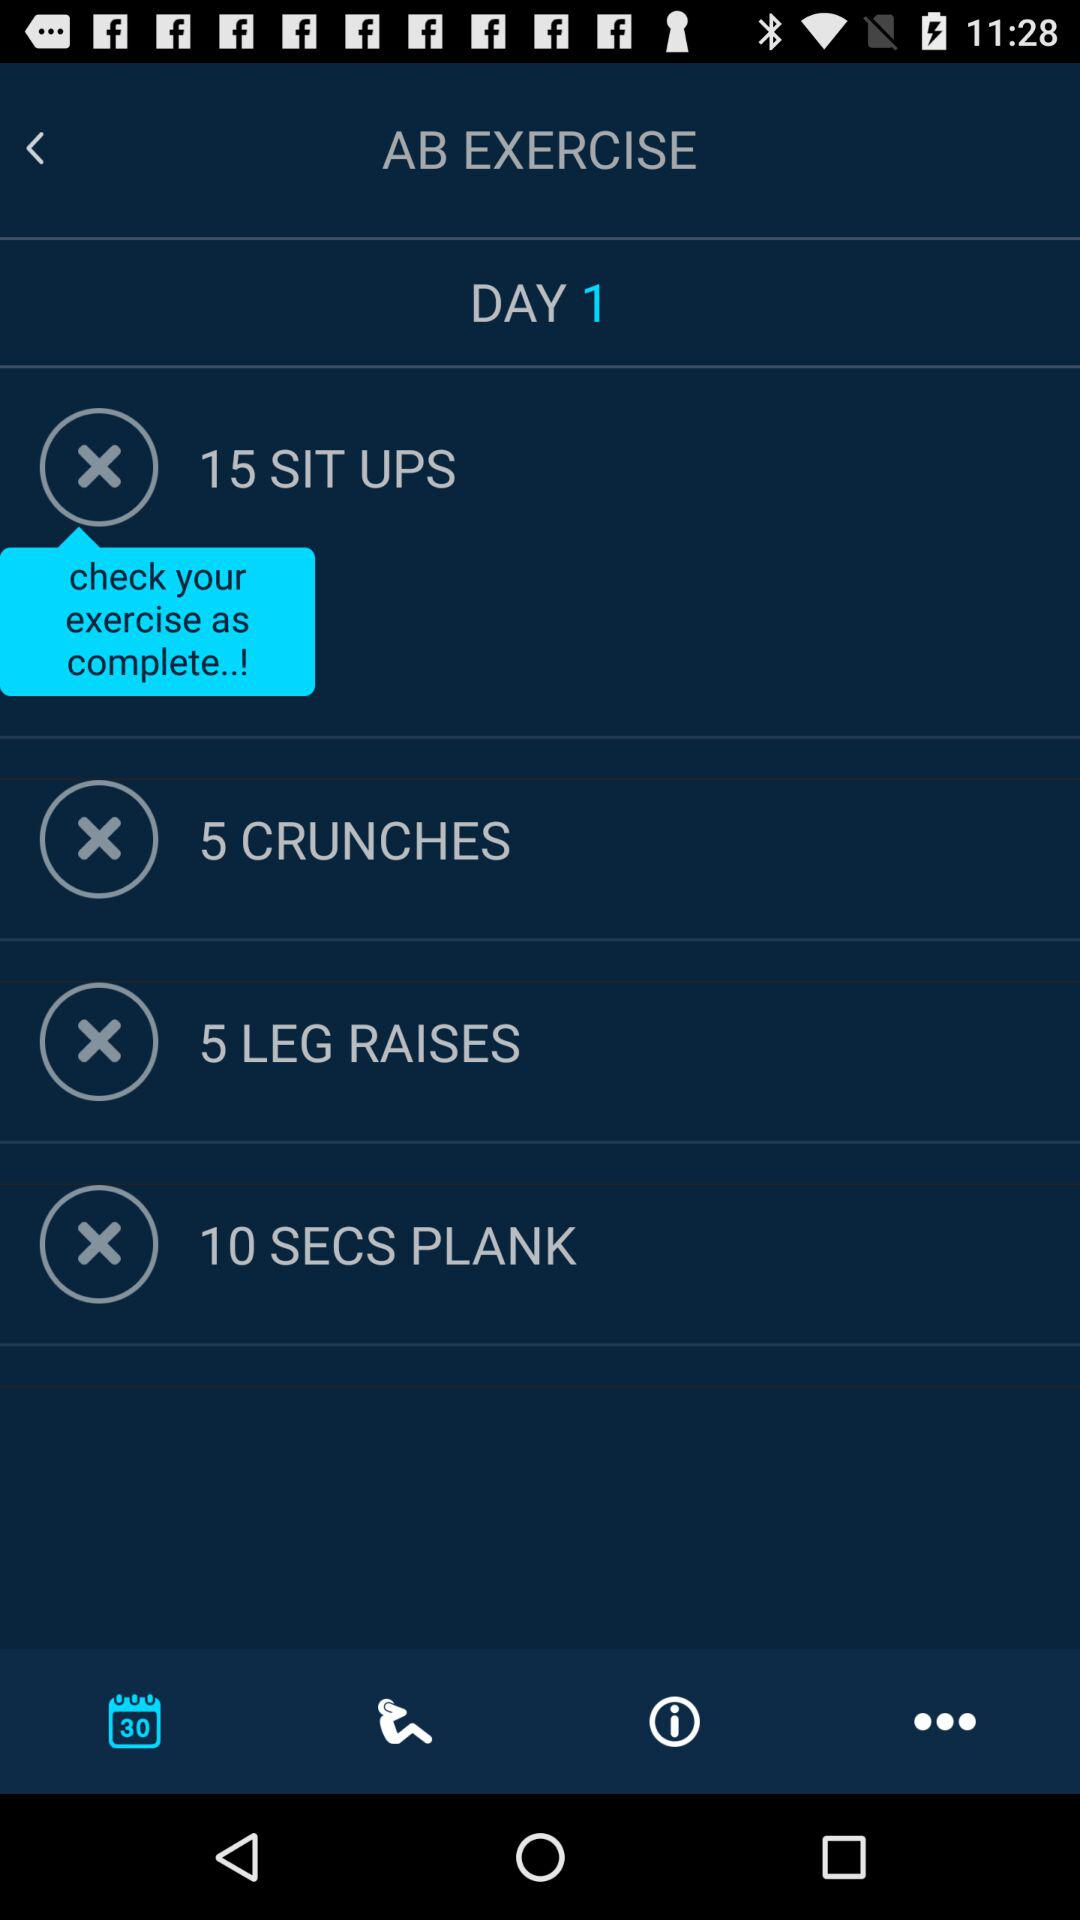How many exercises are in this workout?
Answer the question using a single word or phrase. 4 